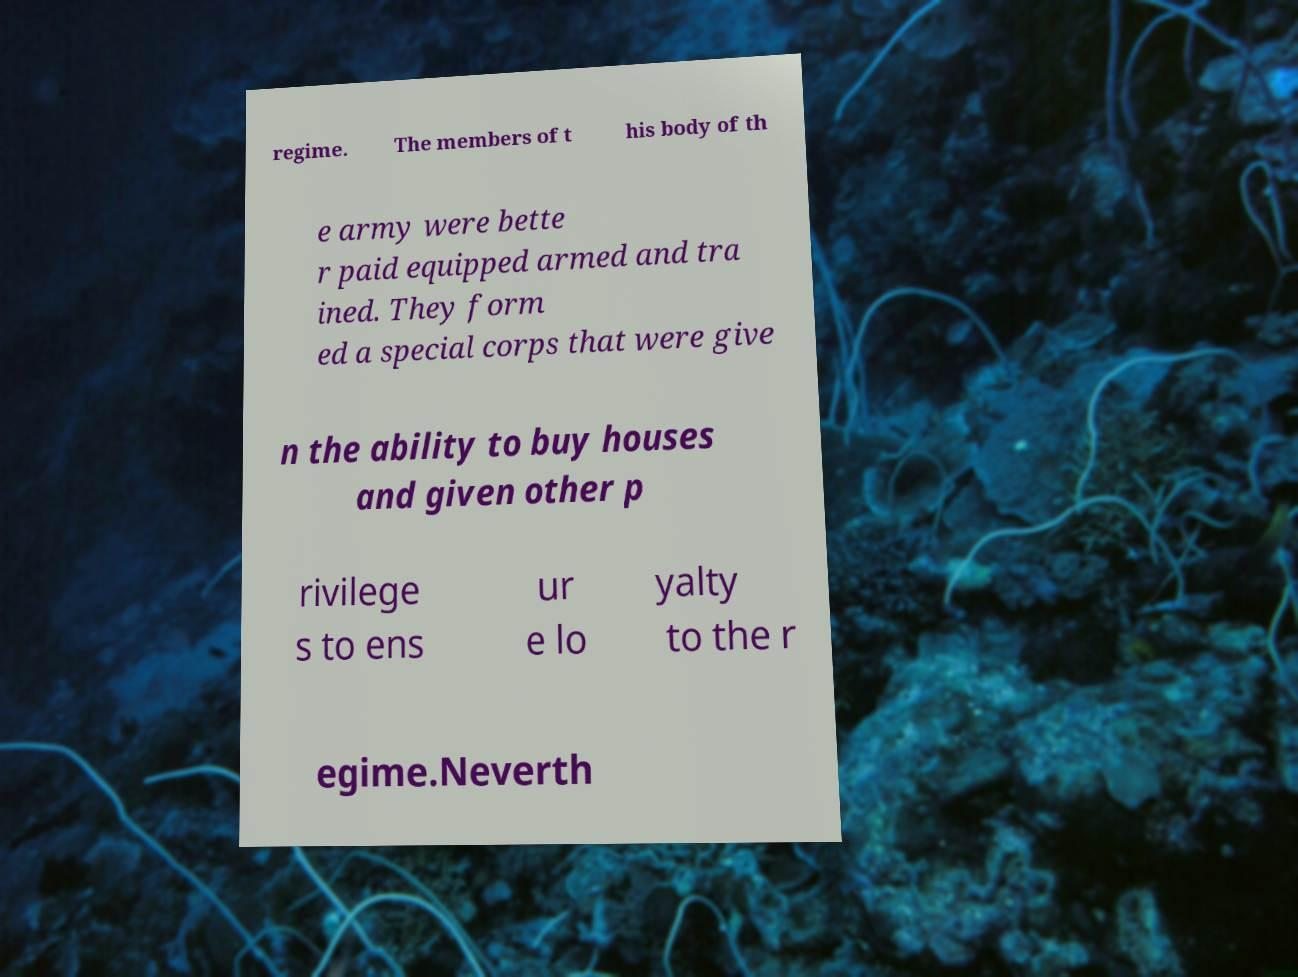I need the written content from this picture converted into text. Can you do that? regime. The members of t his body of th e army were bette r paid equipped armed and tra ined. They form ed a special corps that were give n the ability to buy houses and given other p rivilege s to ens ur e lo yalty to the r egime.Neverth 